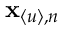Convert formula to latex. <formula><loc_0><loc_0><loc_500><loc_500>x _ { \langle u \rangle , n }</formula> 